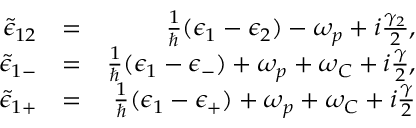Convert formula to latex. <formula><loc_0><loc_0><loc_500><loc_500>\begin{array} { r l r } { \tilde { \epsilon } _ { 1 2 } } & { = } & { \frac { 1 } { } ( \epsilon _ { 1 } - \epsilon _ { 2 } ) - \omega _ { p } + i \frac { \gamma _ { 2 } } { 2 } , } \\ { \tilde { \epsilon } _ { 1 - } } & { = } & { \frac { 1 } { } ( \epsilon _ { 1 } - \epsilon _ { - } ) + \omega _ { p } + \omega _ { C } + i \frac { \gamma } { 2 } , } \\ { \tilde { \epsilon } _ { 1 + } } & { = } & { \frac { 1 } { } ( \epsilon _ { 1 } - \epsilon _ { + } ) + \omega _ { p } + \omega _ { C } + i \frac { \gamma } { 2 } } \end{array}</formula> 